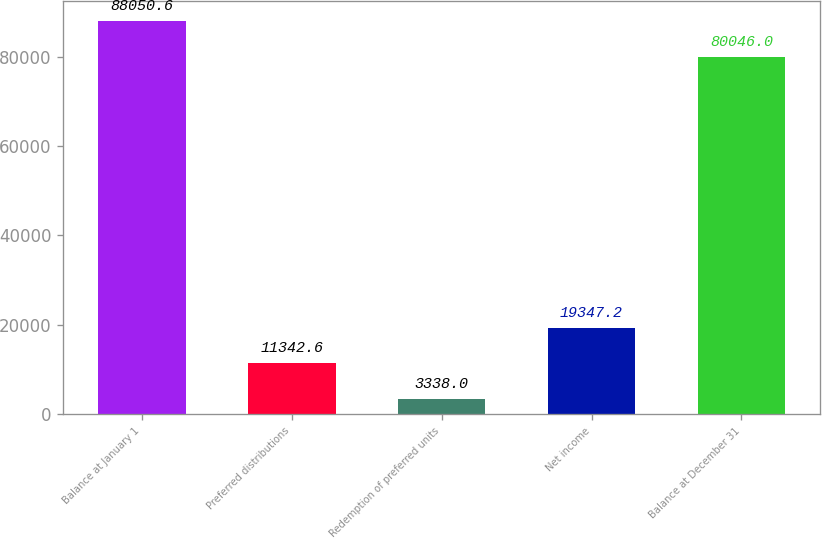<chart> <loc_0><loc_0><loc_500><loc_500><bar_chart><fcel>Balance at January 1<fcel>Preferred distributions<fcel>Redemption of preferred units<fcel>Net income<fcel>Balance at December 31<nl><fcel>88050.6<fcel>11342.6<fcel>3338<fcel>19347.2<fcel>80046<nl></chart> 